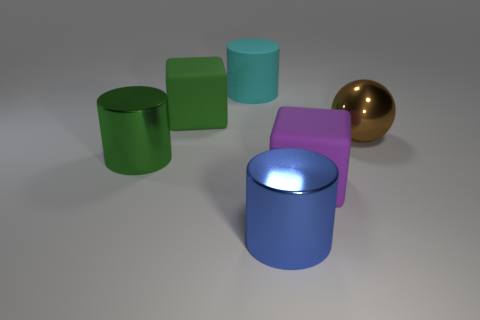There is another object that is the same shape as the large green rubber object; what material is it?
Offer a very short reply. Rubber. Is there a large cyan cylinder?
Offer a terse response. Yes. What is the cylinder that is in front of the large cyan matte thing and to the right of the large green rubber thing made of?
Give a very brief answer. Metal. Are there more matte objects left of the matte cylinder than big blue metal cylinders that are behind the large green block?
Keep it short and to the point. Yes. Is there a green block of the same size as the sphere?
Provide a succinct answer. Yes. There is a metallic thing to the right of the big cylinder that is in front of the cube to the right of the blue metallic object; what is its size?
Give a very brief answer. Large. The metallic ball has what color?
Your answer should be compact. Brown. Is the number of large matte cubes right of the big green cylinder greater than the number of big purple metal spheres?
Your answer should be very brief. Yes. There is a large green cylinder; how many cyan cylinders are on the left side of it?
Your response must be concise. 0. There is a large block in front of the large green cylinder that is in front of the ball; is there a large object that is on the left side of it?
Give a very brief answer. Yes. 